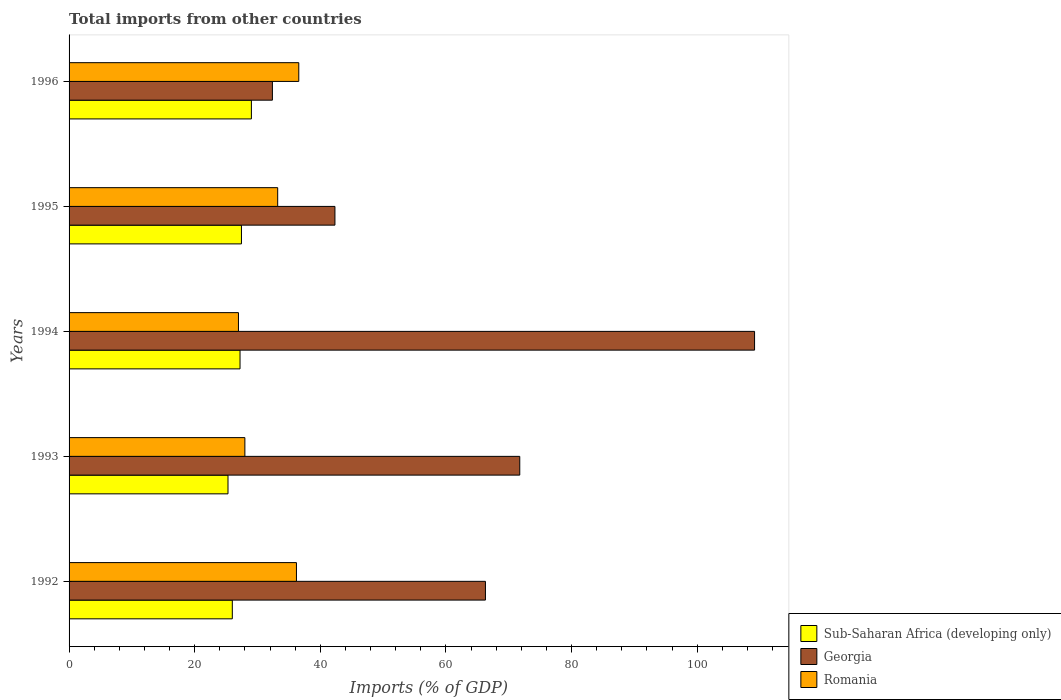Are the number of bars per tick equal to the number of legend labels?
Offer a very short reply. Yes. Are the number of bars on each tick of the Y-axis equal?
Ensure brevity in your answer.  Yes. In how many cases, is the number of bars for a given year not equal to the number of legend labels?
Your answer should be very brief. 0. What is the total imports in Sub-Saharan Africa (developing only) in 1995?
Offer a very short reply. 27.44. Across all years, what is the maximum total imports in Georgia?
Make the answer very short. 109.13. Across all years, what is the minimum total imports in Georgia?
Offer a terse response. 32.37. In which year was the total imports in Romania maximum?
Provide a short and direct response. 1996. What is the total total imports in Sub-Saharan Africa (developing only) in the graph?
Keep it short and to the point. 134.98. What is the difference between the total imports in Sub-Saharan Africa (developing only) in 1992 and that in 1995?
Offer a terse response. -1.45. What is the difference between the total imports in Georgia in 1994 and the total imports in Sub-Saharan Africa (developing only) in 1993?
Provide a succinct answer. 83.83. What is the average total imports in Sub-Saharan Africa (developing only) per year?
Provide a succinct answer. 27. In the year 1996, what is the difference between the total imports in Romania and total imports in Sub-Saharan Africa (developing only)?
Offer a very short reply. 7.54. What is the ratio of the total imports in Georgia in 1993 to that in 1994?
Ensure brevity in your answer.  0.66. Is the difference between the total imports in Romania in 1993 and 1996 greater than the difference between the total imports in Sub-Saharan Africa (developing only) in 1993 and 1996?
Give a very brief answer. No. What is the difference between the highest and the second highest total imports in Sub-Saharan Africa (developing only)?
Provide a succinct answer. 1.58. What is the difference between the highest and the lowest total imports in Romania?
Give a very brief answer. 9.6. In how many years, is the total imports in Georgia greater than the average total imports in Georgia taken over all years?
Give a very brief answer. 3. What does the 3rd bar from the top in 1993 represents?
Provide a short and direct response. Sub-Saharan Africa (developing only). What does the 3rd bar from the bottom in 1996 represents?
Provide a succinct answer. Romania. Are all the bars in the graph horizontal?
Your answer should be compact. Yes. How many years are there in the graph?
Keep it short and to the point. 5. Does the graph contain grids?
Offer a terse response. No. What is the title of the graph?
Offer a very short reply. Total imports from other countries. Does "East Asia (all income levels)" appear as one of the legend labels in the graph?
Make the answer very short. No. What is the label or title of the X-axis?
Give a very brief answer. Imports (% of GDP). What is the Imports (% of GDP) in Sub-Saharan Africa (developing only) in 1992?
Offer a very short reply. 25.99. What is the Imports (% of GDP) of Georgia in 1992?
Make the answer very short. 66.29. What is the Imports (% of GDP) in Romania in 1992?
Your answer should be compact. 36.2. What is the Imports (% of GDP) in Sub-Saharan Africa (developing only) in 1993?
Offer a very short reply. 25.3. What is the Imports (% of GDP) of Georgia in 1993?
Provide a succinct answer. 71.75. What is the Imports (% of GDP) of Romania in 1993?
Offer a very short reply. 27.99. What is the Imports (% of GDP) in Sub-Saharan Africa (developing only) in 1994?
Ensure brevity in your answer.  27.22. What is the Imports (% of GDP) in Georgia in 1994?
Keep it short and to the point. 109.13. What is the Imports (% of GDP) in Romania in 1994?
Your answer should be compact. 26.97. What is the Imports (% of GDP) of Sub-Saharan Africa (developing only) in 1995?
Keep it short and to the point. 27.44. What is the Imports (% of GDP) in Georgia in 1995?
Keep it short and to the point. 42.33. What is the Imports (% of GDP) in Romania in 1995?
Keep it short and to the point. 33.21. What is the Imports (% of GDP) of Sub-Saharan Africa (developing only) in 1996?
Offer a terse response. 29.03. What is the Imports (% of GDP) of Georgia in 1996?
Your answer should be compact. 32.37. What is the Imports (% of GDP) of Romania in 1996?
Make the answer very short. 36.57. Across all years, what is the maximum Imports (% of GDP) in Sub-Saharan Africa (developing only)?
Offer a terse response. 29.03. Across all years, what is the maximum Imports (% of GDP) of Georgia?
Your answer should be compact. 109.13. Across all years, what is the maximum Imports (% of GDP) of Romania?
Your response must be concise. 36.57. Across all years, what is the minimum Imports (% of GDP) in Sub-Saharan Africa (developing only)?
Your answer should be very brief. 25.3. Across all years, what is the minimum Imports (% of GDP) in Georgia?
Keep it short and to the point. 32.37. Across all years, what is the minimum Imports (% of GDP) in Romania?
Provide a short and direct response. 26.97. What is the total Imports (% of GDP) in Sub-Saharan Africa (developing only) in the graph?
Your answer should be compact. 134.98. What is the total Imports (% of GDP) in Georgia in the graph?
Provide a succinct answer. 321.86. What is the total Imports (% of GDP) in Romania in the graph?
Ensure brevity in your answer.  160.93. What is the difference between the Imports (% of GDP) in Sub-Saharan Africa (developing only) in 1992 and that in 1993?
Offer a terse response. 0.69. What is the difference between the Imports (% of GDP) in Georgia in 1992 and that in 1993?
Your response must be concise. -5.46. What is the difference between the Imports (% of GDP) in Romania in 1992 and that in 1993?
Keep it short and to the point. 8.21. What is the difference between the Imports (% of GDP) of Sub-Saharan Africa (developing only) in 1992 and that in 1994?
Your answer should be very brief. -1.23. What is the difference between the Imports (% of GDP) in Georgia in 1992 and that in 1994?
Your response must be concise. -42.84. What is the difference between the Imports (% of GDP) in Romania in 1992 and that in 1994?
Make the answer very short. 9.23. What is the difference between the Imports (% of GDP) of Sub-Saharan Africa (developing only) in 1992 and that in 1995?
Your answer should be compact. -1.45. What is the difference between the Imports (% of GDP) of Georgia in 1992 and that in 1995?
Your answer should be very brief. 23.96. What is the difference between the Imports (% of GDP) in Romania in 1992 and that in 1995?
Your answer should be compact. 2.99. What is the difference between the Imports (% of GDP) of Sub-Saharan Africa (developing only) in 1992 and that in 1996?
Provide a short and direct response. -3.04. What is the difference between the Imports (% of GDP) in Georgia in 1992 and that in 1996?
Ensure brevity in your answer.  33.92. What is the difference between the Imports (% of GDP) of Romania in 1992 and that in 1996?
Your answer should be very brief. -0.37. What is the difference between the Imports (% of GDP) in Sub-Saharan Africa (developing only) in 1993 and that in 1994?
Provide a short and direct response. -1.91. What is the difference between the Imports (% of GDP) of Georgia in 1993 and that in 1994?
Your response must be concise. -37.38. What is the difference between the Imports (% of GDP) in Romania in 1993 and that in 1994?
Give a very brief answer. 1.02. What is the difference between the Imports (% of GDP) in Sub-Saharan Africa (developing only) in 1993 and that in 1995?
Your answer should be compact. -2.14. What is the difference between the Imports (% of GDP) in Georgia in 1993 and that in 1995?
Provide a succinct answer. 29.42. What is the difference between the Imports (% of GDP) of Romania in 1993 and that in 1995?
Give a very brief answer. -5.23. What is the difference between the Imports (% of GDP) in Sub-Saharan Africa (developing only) in 1993 and that in 1996?
Keep it short and to the point. -3.72. What is the difference between the Imports (% of GDP) of Georgia in 1993 and that in 1996?
Make the answer very short. 39.38. What is the difference between the Imports (% of GDP) in Romania in 1993 and that in 1996?
Ensure brevity in your answer.  -8.58. What is the difference between the Imports (% of GDP) of Sub-Saharan Africa (developing only) in 1994 and that in 1995?
Provide a succinct answer. -0.23. What is the difference between the Imports (% of GDP) in Georgia in 1994 and that in 1995?
Keep it short and to the point. 66.8. What is the difference between the Imports (% of GDP) of Romania in 1994 and that in 1995?
Your answer should be very brief. -6.25. What is the difference between the Imports (% of GDP) in Sub-Saharan Africa (developing only) in 1994 and that in 1996?
Keep it short and to the point. -1.81. What is the difference between the Imports (% of GDP) of Georgia in 1994 and that in 1996?
Offer a very short reply. 76.76. What is the difference between the Imports (% of GDP) in Romania in 1994 and that in 1996?
Your answer should be very brief. -9.6. What is the difference between the Imports (% of GDP) of Sub-Saharan Africa (developing only) in 1995 and that in 1996?
Your answer should be compact. -1.58. What is the difference between the Imports (% of GDP) of Georgia in 1995 and that in 1996?
Your response must be concise. 9.96. What is the difference between the Imports (% of GDP) of Romania in 1995 and that in 1996?
Offer a very short reply. -3.36. What is the difference between the Imports (% of GDP) of Sub-Saharan Africa (developing only) in 1992 and the Imports (% of GDP) of Georgia in 1993?
Give a very brief answer. -45.76. What is the difference between the Imports (% of GDP) in Sub-Saharan Africa (developing only) in 1992 and the Imports (% of GDP) in Romania in 1993?
Keep it short and to the point. -2. What is the difference between the Imports (% of GDP) in Georgia in 1992 and the Imports (% of GDP) in Romania in 1993?
Offer a very short reply. 38.3. What is the difference between the Imports (% of GDP) in Sub-Saharan Africa (developing only) in 1992 and the Imports (% of GDP) in Georgia in 1994?
Your answer should be very brief. -83.14. What is the difference between the Imports (% of GDP) of Sub-Saharan Africa (developing only) in 1992 and the Imports (% of GDP) of Romania in 1994?
Keep it short and to the point. -0.98. What is the difference between the Imports (% of GDP) of Georgia in 1992 and the Imports (% of GDP) of Romania in 1994?
Keep it short and to the point. 39.32. What is the difference between the Imports (% of GDP) in Sub-Saharan Africa (developing only) in 1992 and the Imports (% of GDP) in Georgia in 1995?
Provide a short and direct response. -16.34. What is the difference between the Imports (% of GDP) of Sub-Saharan Africa (developing only) in 1992 and the Imports (% of GDP) of Romania in 1995?
Ensure brevity in your answer.  -7.22. What is the difference between the Imports (% of GDP) in Georgia in 1992 and the Imports (% of GDP) in Romania in 1995?
Make the answer very short. 33.07. What is the difference between the Imports (% of GDP) in Sub-Saharan Africa (developing only) in 1992 and the Imports (% of GDP) in Georgia in 1996?
Your answer should be very brief. -6.38. What is the difference between the Imports (% of GDP) in Sub-Saharan Africa (developing only) in 1992 and the Imports (% of GDP) in Romania in 1996?
Offer a very short reply. -10.58. What is the difference between the Imports (% of GDP) of Georgia in 1992 and the Imports (% of GDP) of Romania in 1996?
Offer a terse response. 29.72. What is the difference between the Imports (% of GDP) of Sub-Saharan Africa (developing only) in 1993 and the Imports (% of GDP) of Georgia in 1994?
Your response must be concise. -83.83. What is the difference between the Imports (% of GDP) in Sub-Saharan Africa (developing only) in 1993 and the Imports (% of GDP) in Romania in 1994?
Make the answer very short. -1.66. What is the difference between the Imports (% of GDP) in Georgia in 1993 and the Imports (% of GDP) in Romania in 1994?
Offer a very short reply. 44.78. What is the difference between the Imports (% of GDP) of Sub-Saharan Africa (developing only) in 1993 and the Imports (% of GDP) of Georgia in 1995?
Give a very brief answer. -17.02. What is the difference between the Imports (% of GDP) in Sub-Saharan Africa (developing only) in 1993 and the Imports (% of GDP) in Romania in 1995?
Offer a terse response. -7.91. What is the difference between the Imports (% of GDP) in Georgia in 1993 and the Imports (% of GDP) in Romania in 1995?
Provide a short and direct response. 38.54. What is the difference between the Imports (% of GDP) in Sub-Saharan Africa (developing only) in 1993 and the Imports (% of GDP) in Georgia in 1996?
Provide a succinct answer. -7.07. What is the difference between the Imports (% of GDP) in Sub-Saharan Africa (developing only) in 1993 and the Imports (% of GDP) in Romania in 1996?
Make the answer very short. -11.27. What is the difference between the Imports (% of GDP) of Georgia in 1993 and the Imports (% of GDP) of Romania in 1996?
Keep it short and to the point. 35.18. What is the difference between the Imports (% of GDP) in Sub-Saharan Africa (developing only) in 1994 and the Imports (% of GDP) in Georgia in 1995?
Keep it short and to the point. -15.11. What is the difference between the Imports (% of GDP) in Sub-Saharan Africa (developing only) in 1994 and the Imports (% of GDP) in Romania in 1995?
Your answer should be compact. -6. What is the difference between the Imports (% of GDP) of Georgia in 1994 and the Imports (% of GDP) of Romania in 1995?
Your answer should be very brief. 75.92. What is the difference between the Imports (% of GDP) of Sub-Saharan Africa (developing only) in 1994 and the Imports (% of GDP) of Georgia in 1996?
Your answer should be compact. -5.15. What is the difference between the Imports (% of GDP) of Sub-Saharan Africa (developing only) in 1994 and the Imports (% of GDP) of Romania in 1996?
Keep it short and to the point. -9.35. What is the difference between the Imports (% of GDP) of Georgia in 1994 and the Imports (% of GDP) of Romania in 1996?
Ensure brevity in your answer.  72.56. What is the difference between the Imports (% of GDP) in Sub-Saharan Africa (developing only) in 1995 and the Imports (% of GDP) in Georgia in 1996?
Provide a short and direct response. -4.93. What is the difference between the Imports (% of GDP) of Sub-Saharan Africa (developing only) in 1995 and the Imports (% of GDP) of Romania in 1996?
Give a very brief answer. -9.13. What is the difference between the Imports (% of GDP) in Georgia in 1995 and the Imports (% of GDP) in Romania in 1996?
Offer a terse response. 5.76. What is the average Imports (% of GDP) of Sub-Saharan Africa (developing only) per year?
Provide a succinct answer. 27. What is the average Imports (% of GDP) of Georgia per year?
Provide a short and direct response. 64.37. What is the average Imports (% of GDP) in Romania per year?
Your answer should be compact. 32.19. In the year 1992, what is the difference between the Imports (% of GDP) in Sub-Saharan Africa (developing only) and Imports (% of GDP) in Georgia?
Your answer should be compact. -40.3. In the year 1992, what is the difference between the Imports (% of GDP) in Sub-Saharan Africa (developing only) and Imports (% of GDP) in Romania?
Make the answer very short. -10.21. In the year 1992, what is the difference between the Imports (% of GDP) of Georgia and Imports (% of GDP) of Romania?
Make the answer very short. 30.09. In the year 1993, what is the difference between the Imports (% of GDP) in Sub-Saharan Africa (developing only) and Imports (% of GDP) in Georgia?
Provide a succinct answer. -46.45. In the year 1993, what is the difference between the Imports (% of GDP) in Sub-Saharan Africa (developing only) and Imports (% of GDP) in Romania?
Your answer should be very brief. -2.68. In the year 1993, what is the difference between the Imports (% of GDP) in Georgia and Imports (% of GDP) in Romania?
Provide a succinct answer. 43.76. In the year 1994, what is the difference between the Imports (% of GDP) in Sub-Saharan Africa (developing only) and Imports (% of GDP) in Georgia?
Provide a short and direct response. -81.91. In the year 1994, what is the difference between the Imports (% of GDP) in Sub-Saharan Africa (developing only) and Imports (% of GDP) in Romania?
Offer a very short reply. 0.25. In the year 1994, what is the difference between the Imports (% of GDP) of Georgia and Imports (% of GDP) of Romania?
Offer a terse response. 82.16. In the year 1995, what is the difference between the Imports (% of GDP) in Sub-Saharan Africa (developing only) and Imports (% of GDP) in Georgia?
Make the answer very short. -14.88. In the year 1995, what is the difference between the Imports (% of GDP) in Sub-Saharan Africa (developing only) and Imports (% of GDP) in Romania?
Ensure brevity in your answer.  -5.77. In the year 1995, what is the difference between the Imports (% of GDP) in Georgia and Imports (% of GDP) in Romania?
Ensure brevity in your answer.  9.11. In the year 1996, what is the difference between the Imports (% of GDP) of Sub-Saharan Africa (developing only) and Imports (% of GDP) of Georgia?
Make the answer very short. -3.34. In the year 1996, what is the difference between the Imports (% of GDP) in Sub-Saharan Africa (developing only) and Imports (% of GDP) in Romania?
Give a very brief answer. -7.54. In the year 1996, what is the difference between the Imports (% of GDP) of Georgia and Imports (% of GDP) of Romania?
Provide a succinct answer. -4.2. What is the ratio of the Imports (% of GDP) in Sub-Saharan Africa (developing only) in 1992 to that in 1993?
Offer a terse response. 1.03. What is the ratio of the Imports (% of GDP) of Georgia in 1992 to that in 1993?
Give a very brief answer. 0.92. What is the ratio of the Imports (% of GDP) of Romania in 1992 to that in 1993?
Your answer should be very brief. 1.29. What is the ratio of the Imports (% of GDP) in Sub-Saharan Africa (developing only) in 1992 to that in 1994?
Give a very brief answer. 0.95. What is the ratio of the Imports (% of GDP) in Georgia in 1992 to that in 1994?
Offer a very short reply. 0.61. What is the ratio of the Imports (% of GDP) of Romania in 1992 to that in 1994?
Make the answer very short. 1.34. What is the ratio of the Imports (% of GDP) in Sub-Saharan Africa (developing only) in 1992 to that in 1995?
Your answer should be compact. 0.95. What is the ratio of the Imports (% of GDP) of Georgia in 1992 to that in 1995?
Offer a very short reply. 1.57. What is the ratio of the Imports (% of GDP) of Romania in 1992 to that in 1995?
Make the answer very short. 1.09. What is the ratio of the Imports (% of GDP) of Sub-Saharan Africa (developing only) in 1992 to that in 1996?
Your answer should be compact. 0.9. What is the ratio of the Imports (% of GDP) in Georgia in 1992 to that in 1996?
Make the answer very short. 2.05. What is the ratio of the Imports (% of GDP) in Romania in 1992 to that in 1996?
Make the answer very short. 0.99. What is the ratio of the Imports (% of GDP) of Sub-Saharan Africa (developing only) in 1993 to that in 1994?
Your answer should be compact. 0.93. What is the ratio of the Imports (% of GDP) of Georgia in 1993 to that in 1994?
Your answer should be very brief. 0.66. What is the ratio of the Imports (% of GDP) of Romania in 1993 to that in 1994?
Offer a terse response. 1.04. What is the ratio of the Imports (% of GDP) of Sub-Saharan Africa (developing only) in 1993 to that in 1995?
Offer a very short reply. 0.92. What is the ratio of the Imports (% of GDP) in Georgia in 1993 to that in 1995?
Make the answer very short. 1.7. What is the ratio of the Imports (% of GDP) in Romania in 1993 to that in 1995?
Your answer should be compact. 0.84. What is the ratio of the Imports (% of GDP) of Sub-Saharan Africa (developing only) in 1993 to that in 1996?
Your answer should be compact. 0.87. What is the ratio of the Imports (% of GDP) in Georgia in 1993 to that in 1996?
Keep it short and to the point. 2.22. What is the ratio of the Imports (% of GDP) of Romania in 1993 to that in 1996?
Keep it short and to the point. 0.77. What is the ratio of the Imports (% of GDP) of Georgia in 1994 to that in 1995?
Make the answer very short. 2.58. What is the ratio of the Imports (% of GDP) of Romania in 1994 to that in 1995?
Give a very brief answer. 0.81. What is the ratio of the Imports (% of GDP) in Sub-Saharan Africa (developing only) in 1994 to that in 1996?
Keep it short and to the point. 0.94. What is the ratio of the Imports (% of GDP) of Georgia in 1994 to that in 1996?
Provide a succinct answer. 3.37. What is the ratio of the Imports (% of GDP) of Romania in 1994 to that in 1996?
Provide a short and direct response. 0.74. What is the ratio of the Imports (% of GDP) of Sub-Saharan Africa (developing only) in 1995 to that in 1996?
Ensure brevity in your answer.  0.95. What is the ratio of the Imports (% of GDP) in Georgia in 1995 to that in 1996?
Ensure brevity in your answer.  1.31. What is the ratio of the Imports (% of GDP) of Romania in 1995 to that in 1996?
Keep it short and to the point. 0.91. What is the difference between the highest and the second highest Imports (% of GDP) in Sub-Saharan Africa (developing only)?
Offer a terse response. 1.58. What is the difference between the highest and the second highest Imports (% of GDP) in Georgia?
Provide a succinct answer. 37.38. What is the difference between the highest and the second highest Imports (% of GDP) in Romania?
Your answer should be very brief. 0.37. What is the difference between the highest and the lowest Imports (% of GDP) in Sub-Saharan Africa (developing only)?
Keep it short and to the point. 3.72. What is the difference between the highest and the lowest Imports (% of GDP) in Georgia?
Provide a short and direct response. 76.76. What is the difference between the highest and the lowest Imports (% of GDP) of Romania?
Your response must be concise. 9.6. 